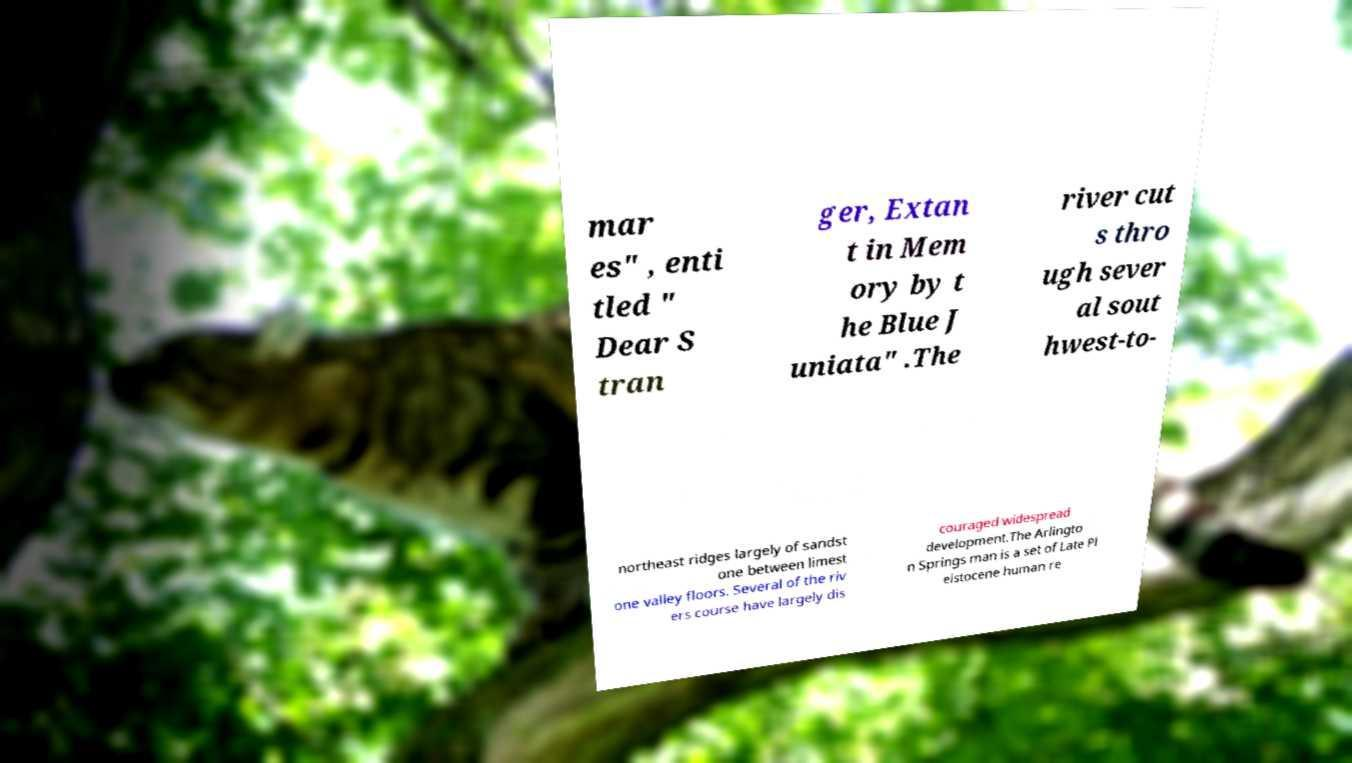What messages or text are displayed in this image? I need them in a readable, typed format. mar es" , enti tled " Dear S tran ger, Extan t in Mem ory by t he Blue J uniata" .The river cut s thro ugh sever al sout hwest-to- northeast ridges largely of sandst one between limest one valley floors. Several of the riv ers course have largely dis couraged widespread development.The Arlingto n Springs man is a set of Late Pl eistocene human re 